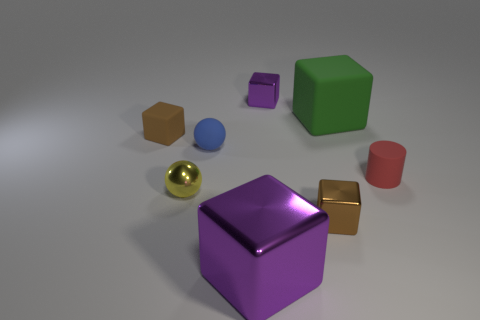What number of tiny balls are behind the red rubber thing?
Offer a terse response. 1. There is a purple metal thing behind the green rubber thing; is it the same size as the brown shiny cube?
Offer a terse response. Yes. What is the color of the other object that is the same shape as the blue thing?
Offer a very short reply. Yellow. Is there anything else that is the same shape as the red thing?
Your response must be concise. No. There is a shiny object that is to the left of the large shiny block; what is its shape?
Your answer should be very brief. Sphere. What number of green things are the same shape as the brown metal object?
Provide a short and direct response. 1. There is a cube that is on the left side of the tiny blue matte sphere; does it have the same color as the tiny metallic cube that is in front of the blue ball?
Offer a very short reply. Yes. What number of objects are small gray metallic balls or small objects?
Provide a short and direct response. 6. What number of tiny yellow blocks have the same material as the cylinder?
Keep it short and to the point. 0. Is the number of green things less than the number of big purple matte balls?
Make the answer very short. No. 